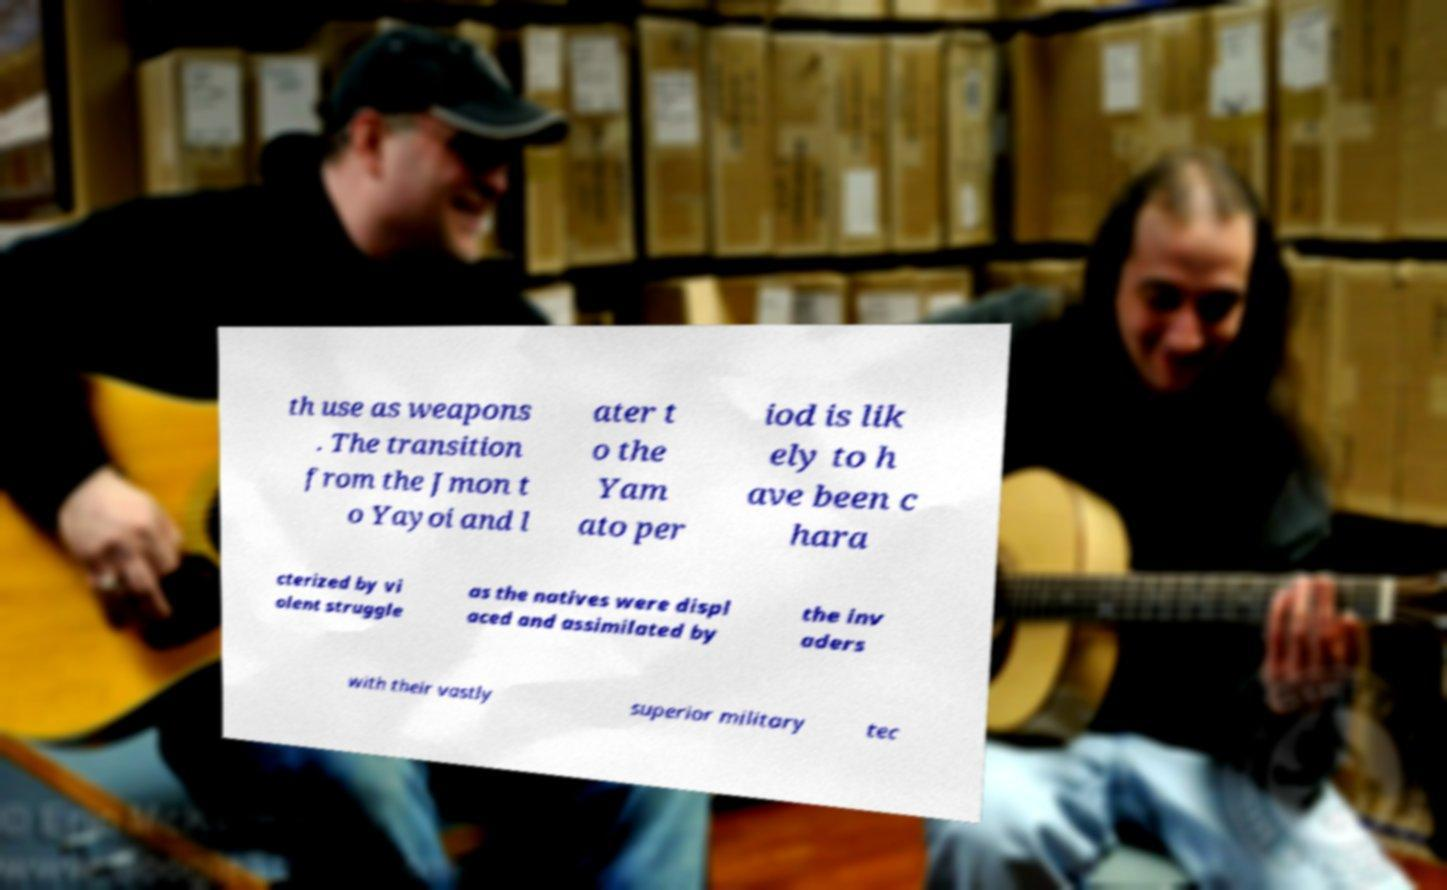Could you extract and type out the text from this image? th use as weapons . The transition from the Jmon t o Yayoi and l ater t o the Yam ato per iod is lik ely to h ave been c hara cterized by vi olent struggle as the natives were displ aced and assimilated by the inv aders with their vastly superior military tec 